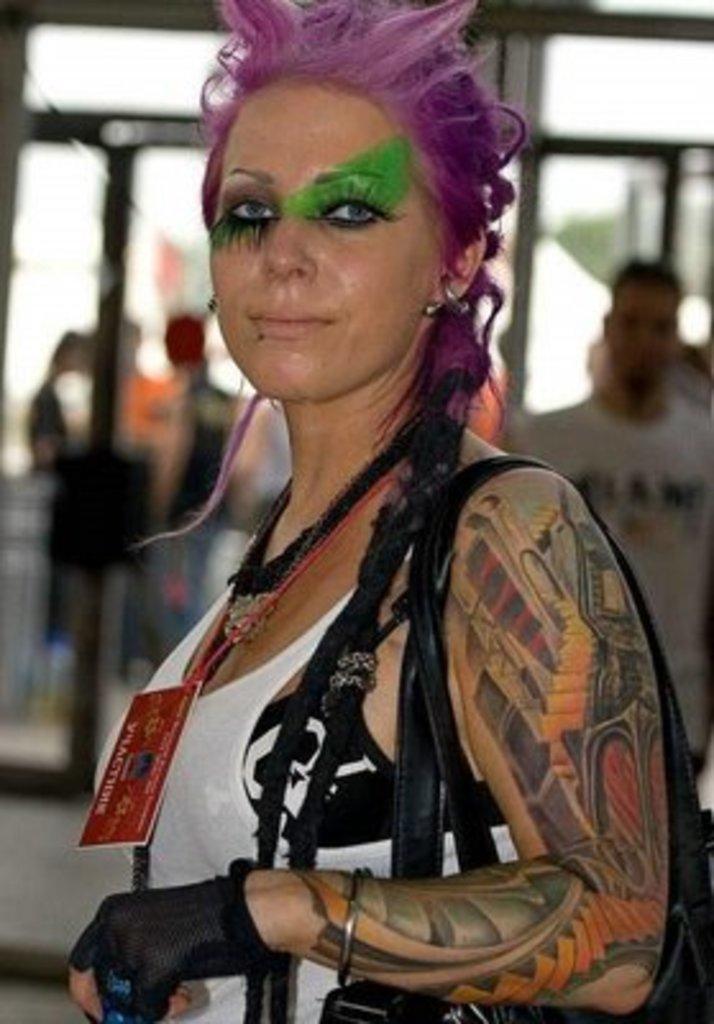In one or two sentences, can you explain what this image depicts? In this image I can see the person with the card. There is a tattoo on the person's hand. In the back I can see few more people with different color dress and it is blurry. 